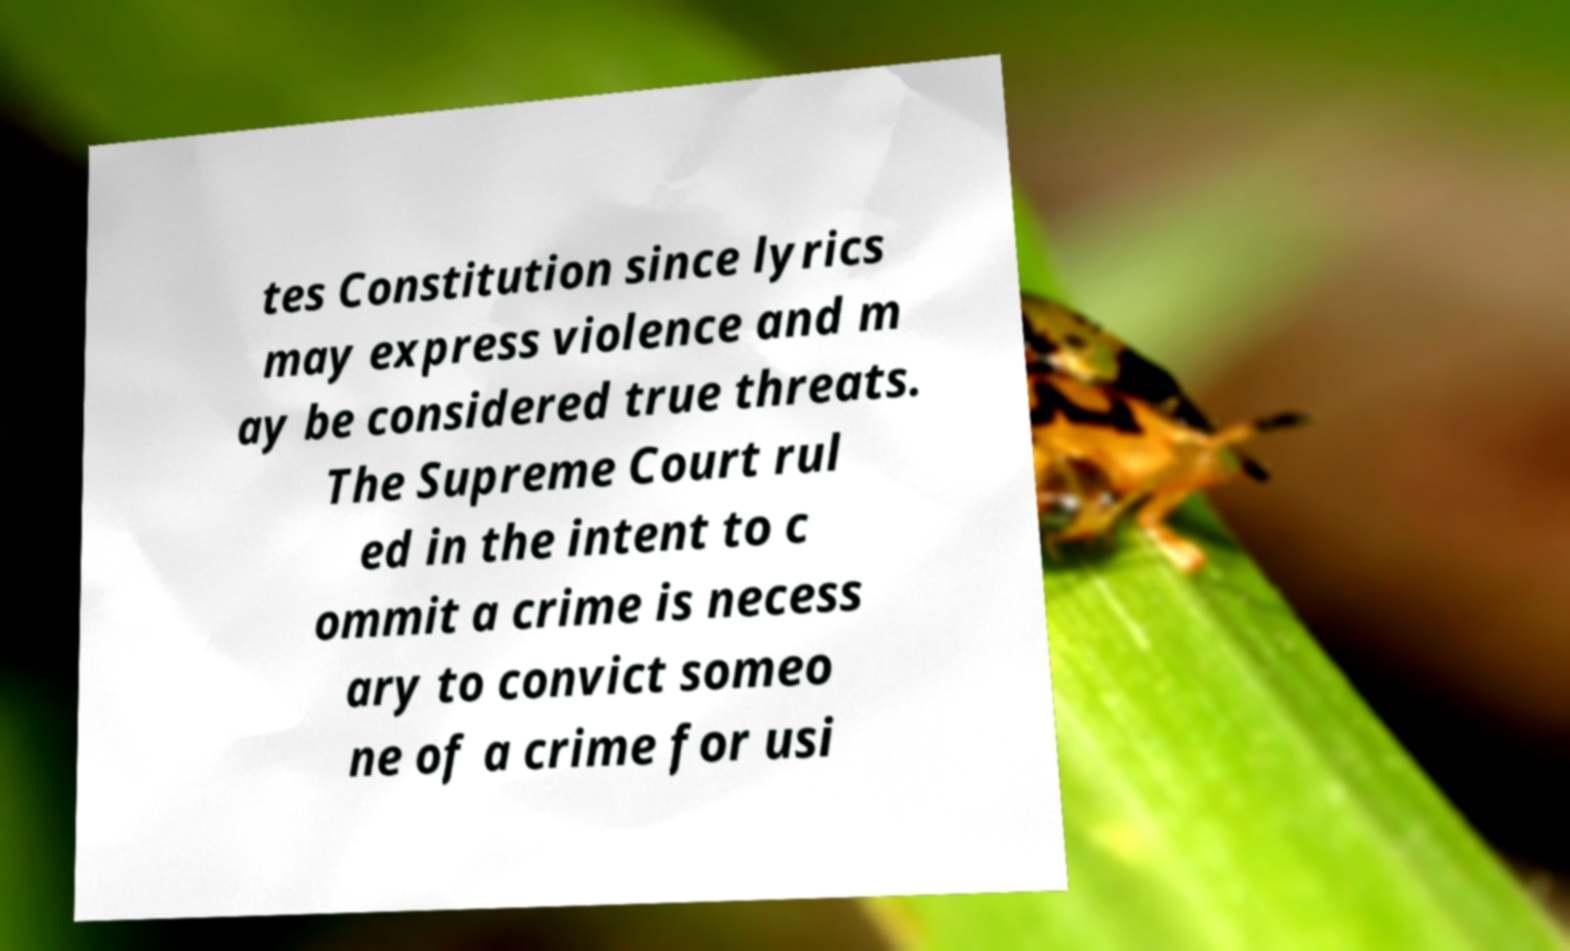Could you extract and type out the text from this image? tes Constitution since lyrics may express violence and m ay be considered true threats. The Supreme Court rul ed in the intent to c ommit a crime is necess ary to convict someo ne of a crime for usi 